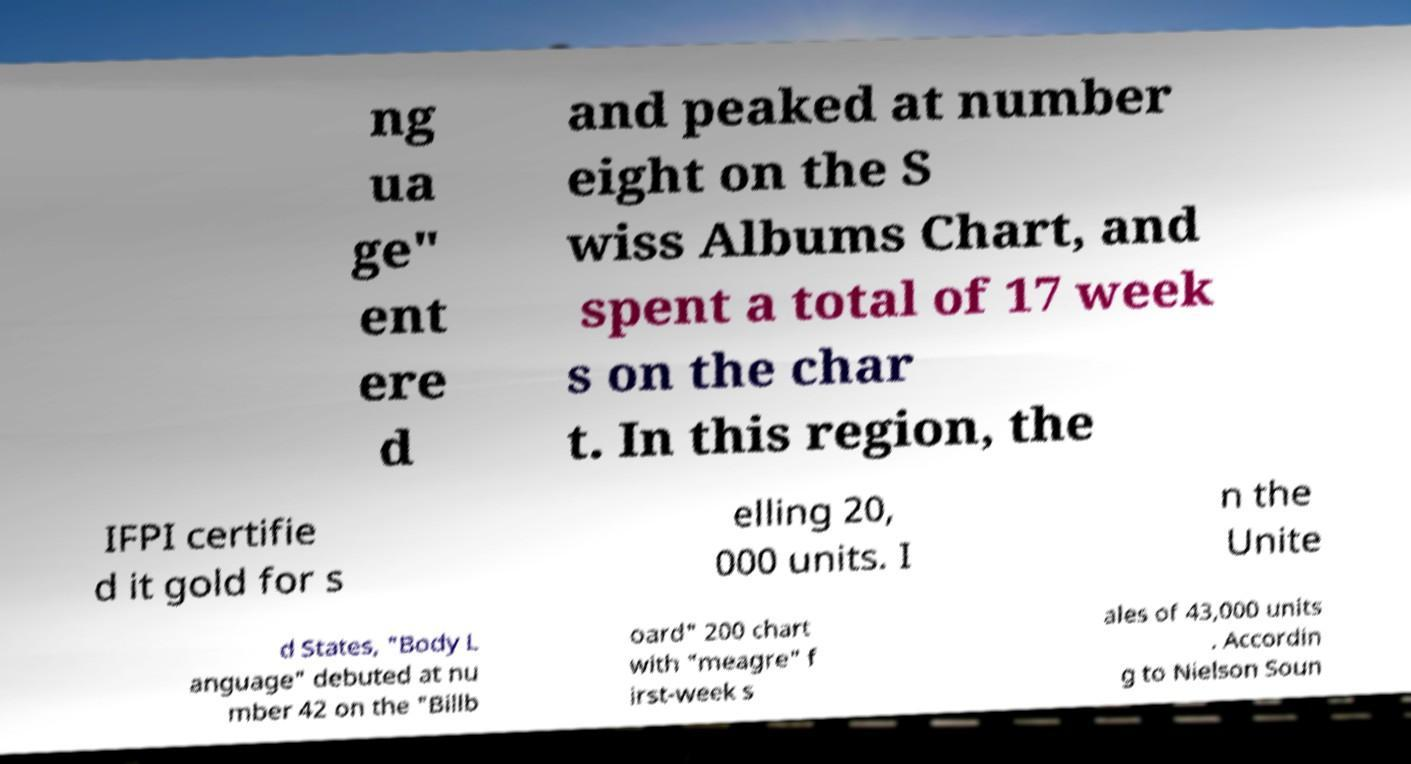For documentation purposes, I need the text within this image transcribed. Could you provide that? ng ua ge" ent ere d and peaked at number eight on the S wiss Albums Chart, and spent a total of 17 week s on the char t. In this region, the IFPI certifie d it gold for s elling 20, 000 units. I n the Unite d States, "Body L anguage" debuted at nu mber 42 on the "Billb oard" 200 chart with "meagre" f irst-week s ales of 43,000 units . Accordin g to Nielson Soun 